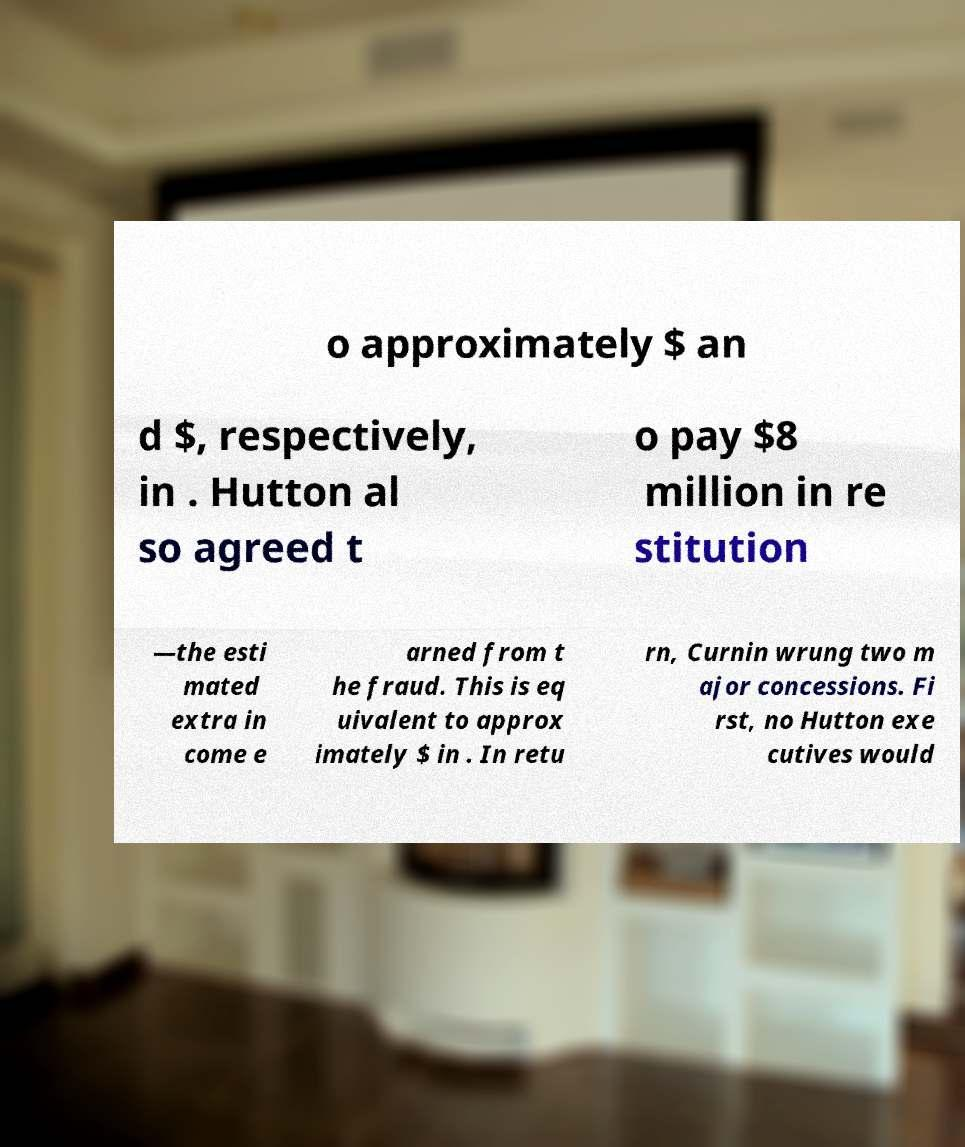For documentation purposes, I need the text within this image transcribed. Could you provide that? o approximately $ an d $, respectively, in . Hutton al so agreed t o pay $8 million in re stitution —the esti mated extra in come e arned from t he fraud. This is eq uivalent to approx imately $ in . In retu rn, Curnin wrung two m ajor concessions. Fi rst, no Hutton exe cutives would 